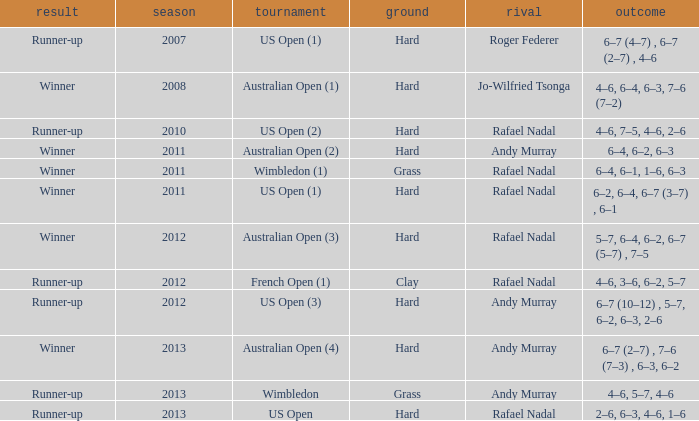What is the outcome of the match with Roger Federer as the opponent? Runner-up. 